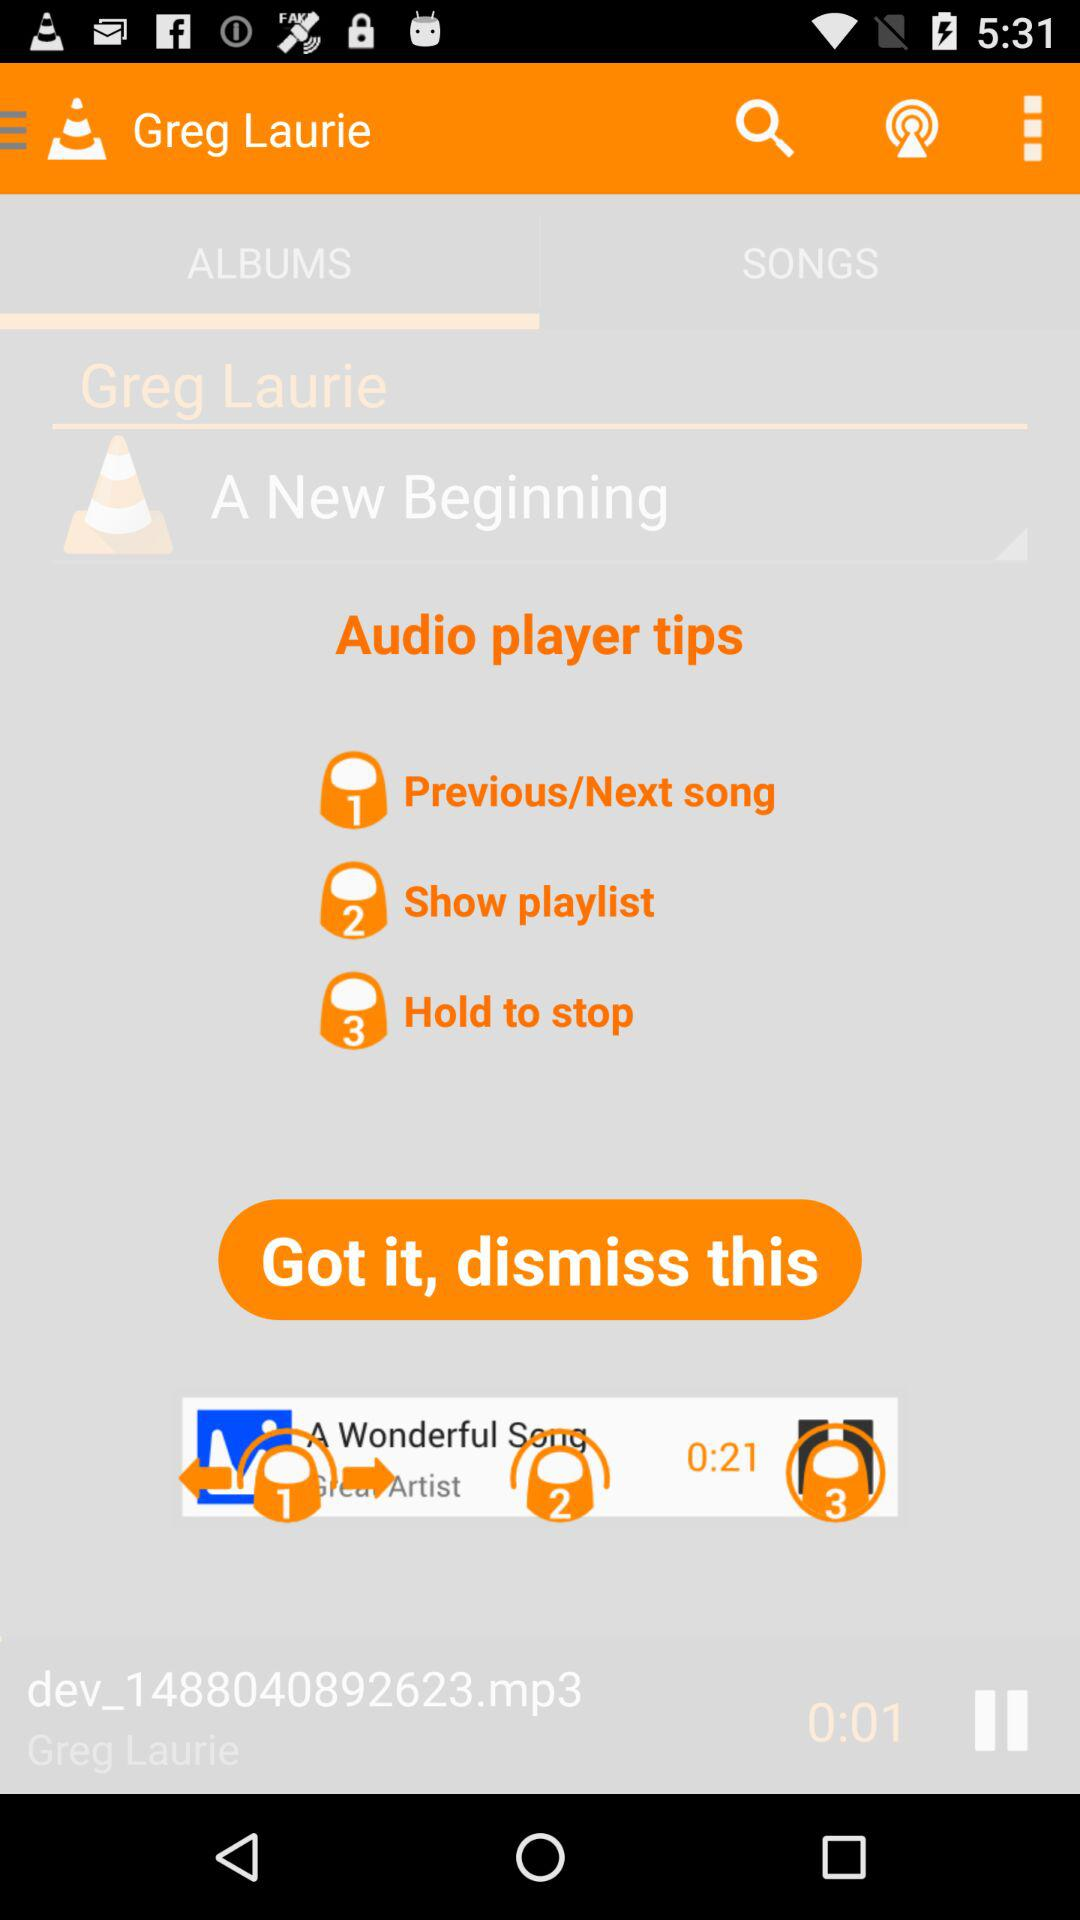What are the audio player tips? The audio player tips are "Previous/Next song", "Show playlist" and "Hold to stop". 